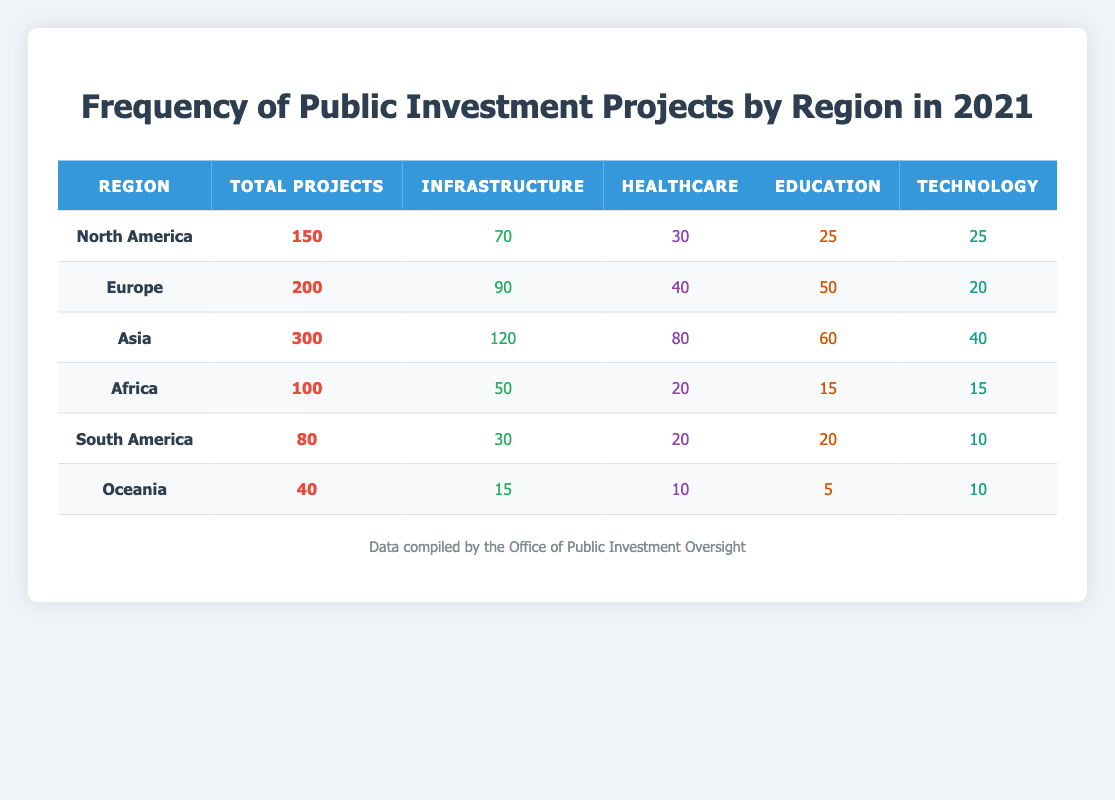What is the total number of public investment projects in Asia? The total number of public investment projects in Asia is explicitly stated in the table under the "Total Projects" column. According to the data, Asia has 300 total projects.
Answer: 300 Which region has the highest number of healthcare projects? To find the region with the highest number of healthcare projects, we compare the "Healthcare" column values. Asia has 80, Europe has 40, North America has 30, Africa has 20, South America has 20, and Oceania has 10. The highest value is 80 in Asia.
Answer: Asia How many more infrastructure projects are there in Europe compared to Africa? To find this, we look at the "Infrastructure" column for both Europe and Africa. Europe has 90 infrastructure projects while Africa has 50. The difference is 90 - 50 = 40.
Answer: 40 What is the average number of education projects across all regions? To calculate the average, we sum the values in the "Education" column: 25 (North America) + 50 (Europe) + 60 (Asia) + 15 (Africa) + 20 (South America) + 5 (Oceania) = 175. There are 6 regions, so the average is 175 / 6 ≈ 29.17.
Answer: 29.17 Is it true that Oceania has more technology projects than South America? We check the "Technology" column for both regions. Oceania has 10 technology projects while South America has 10 as well. Since the numbers are equal, the statement is false.
Answer: No Which region has the lowest total number of public investment projects? By looking at the "Total Projects" column, we find the values are: 150 (North America), 200 (Europe), 300 (Asia), 100 (Africa), 80 (South America), and 40 (Oceania). The lowest value is in Oceania with 40 total projects.
Answer: Oceania What is the total number of healthcare projects across all regions? We sum the values in the "Healthcare" column: 30 (North America) + 40 (Europe) + 80 (Asia) + 20 (Africa) + 20 (South America) + 10 (Oceania) = 200.
Answer: 200 Does Europe have a higher total number of projects than Asia? We compare the total in the "Total Projects" column: Europe has 200 projects while Asia has 300. Therefore, the statement is false as Europe has fewer projects than Asia.
Answer: No What is the difference in total public investment projects between North America and South America? The total projects for North America is 150, while for South America it is 80. The difference is 150 - 80 = 70.
Answer: 70 